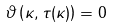Convert formula to latex. <formula><loc_0><loc_0><loc_500><loc_500>\vartheta \left ( \kappa , \tau ( \kappa ) \right ) = 0</formula> 